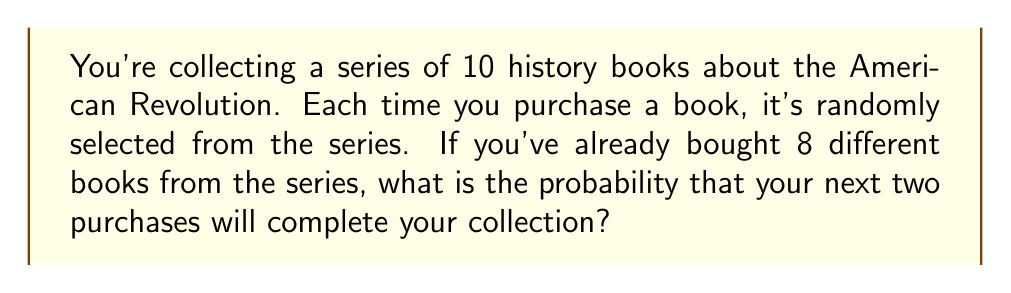Solve this math problem. Let's approach this step-by-step:

1) You have 8 different books, so there are 2 books left to complete the collection.

2) For the first purchase:
   - Probability of getting one of the two needed books: $\frac{2}{10}$

3) For the second purchase:
   - If the first purchase was successful, you need 1 out of the remaining 9 books: $\frac{1}{9}$
   - If the first purchase failed, you still need 2 out of 9 books: $\frac{2}{9}$

4) The probability of both purchases completing your collection is the product of:
   - Getting a needed book on the first purchase AND
   - Getting the last needed book on the second purchase

5) We can express this mathematically as:

   $$P(\text{completing collection}) = \frac{2}{10} \cdot \frac{1}{9} = \frac{1}{45}$$

6) To convert to a percentage:

   $$\frac{1}{45} \approx 0.0222 = 2.22\%$$

Thus, the probability of completing your collection with the next two purchases is approximately 2.22%.
Answer: $\frac{1}{45}$ or 2.22% 